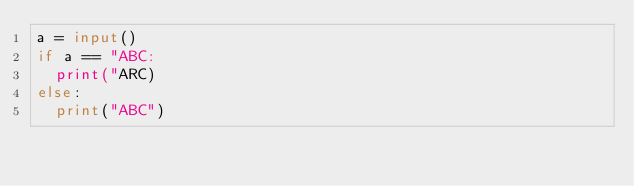<code> <loc_0><loc_0><loc_500><loc_500><_Python_>a = input()
if a == "ABC:
	print("ARC)
else:
	print("ABC")
</code> 